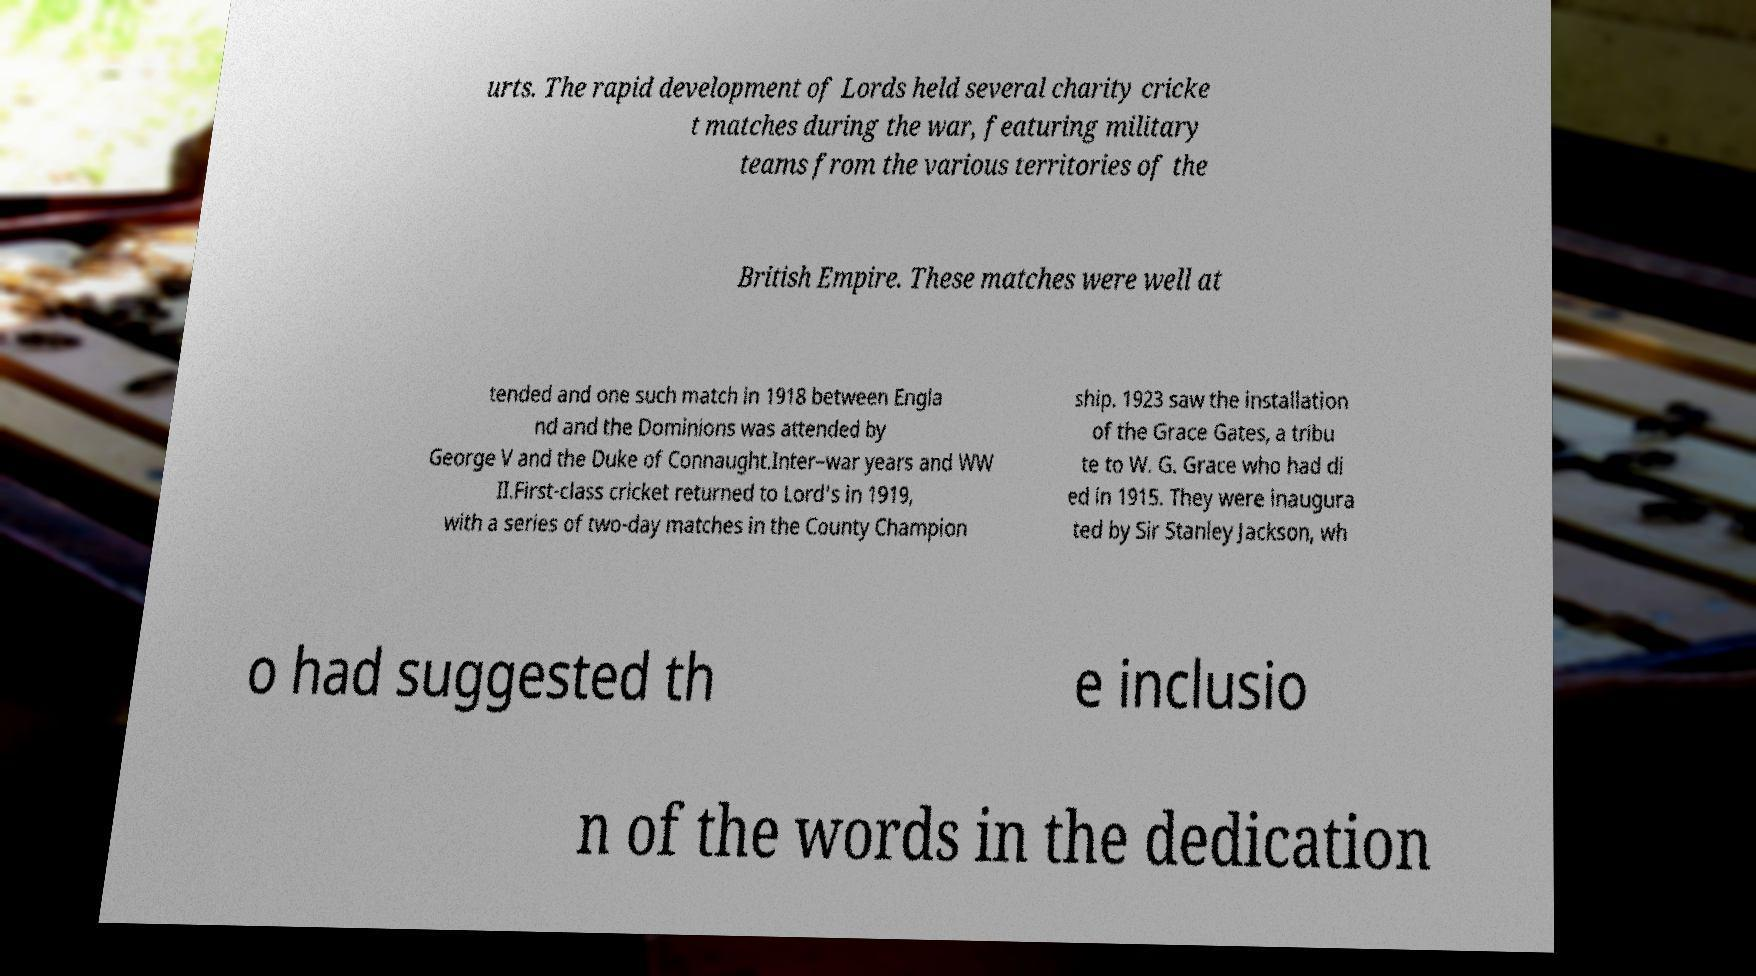I need the written content from this picture converted into text. Can you do that? urts. The rapid development of Lords held several charity cricke t matches during the war, featuring military teams from the various territories of the British Empire. These matches were well at tended and one such match in 1918 between Engla nd and the Dominions was attended by George V and the Duke of Connaught.Inter–war years and WW II.First-class cricket returned to Lord's in 1919, with a series of two-day matches in the County Champion ship. 1923 saw the installation of the Grace Gates, a tribu te to W. G. Grace who had di ed in 1915. They were inaugura ted by Sir Stanley Jackson, wh o had suggested th e inclusio n of the words in the dedication 